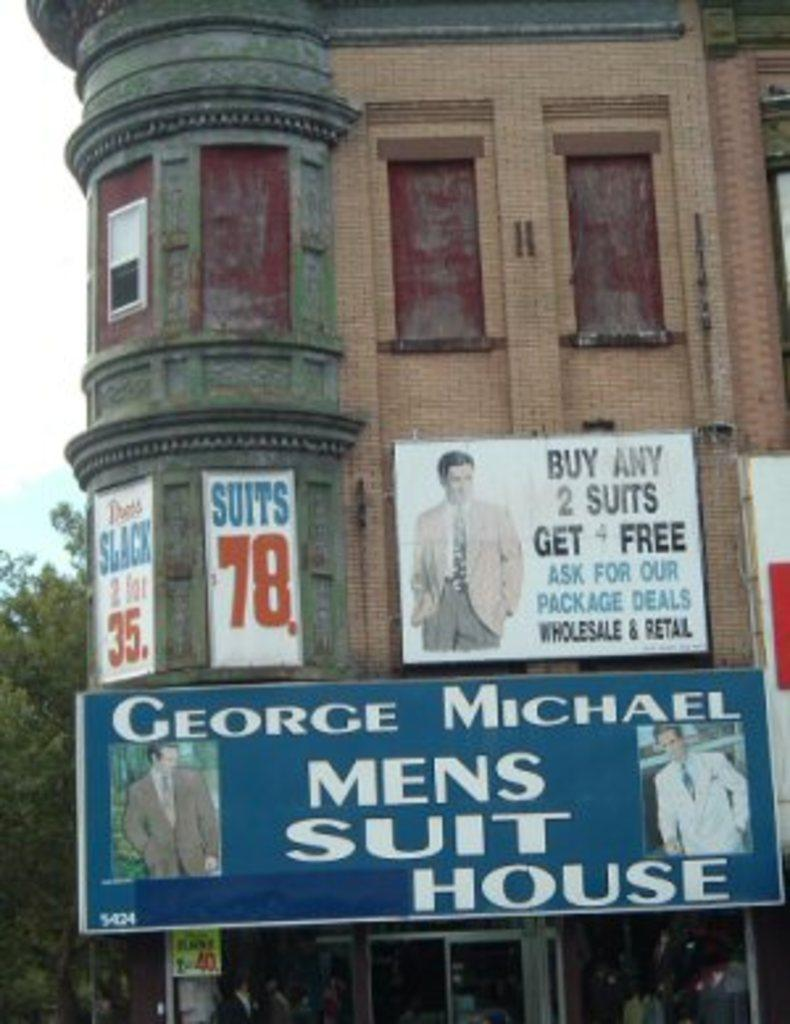What is on the building in the center of the image? There are posters on the building in the center of the image. What can be seen at the bottom side of the image? It appears there are stalls at the bottom side of the image. What type of vegetation is visible in the background of the image? There are trees in the background of the image. What is visible in the sky in the background of the image? The sky is visible in the background of the image. How many dimes are scattered on the ground in the image? There are no dimes visible in the image. Is the image taken during the night or day? The image does not provide any specific information about the time of day, so it cannot be determined if it was taken during the night or day. 